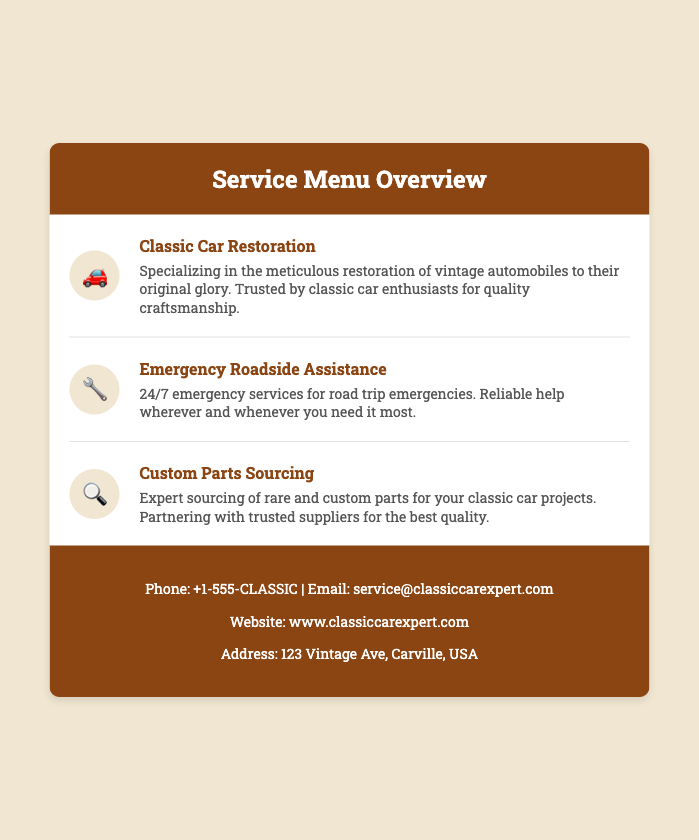What is the title of the card? The title of the card is prominently displayed in the header section.
Answer: Service Menu Overview How many services are listed in the document? The number of services can be counted from the services section.
Answer: Three What icon represents Custom Parts Sourcing? The icon associated with Custom Parts Sourcing is located next to the service name.
Answer: 🔍 What is the phone number provided? The phone number can be found in the contact info section of the card.
Answer: +1-555-CLASSIC What does the Emergency Roadside Assistance service offer? The service description provides details about what this service includes.
Answer: 24/7 emergency services Which service specializes in restoring vintage automobiles? This information is included in the service name section.
Answer: Classic Car Restoration What color is the header of the card? The background color of the header is mentioned in the style section of the document.
Answer: #8b4513 Where is the business located? The address is listed in the contact information section.
Answer: 123 Vintage Ave, Carville, USA 